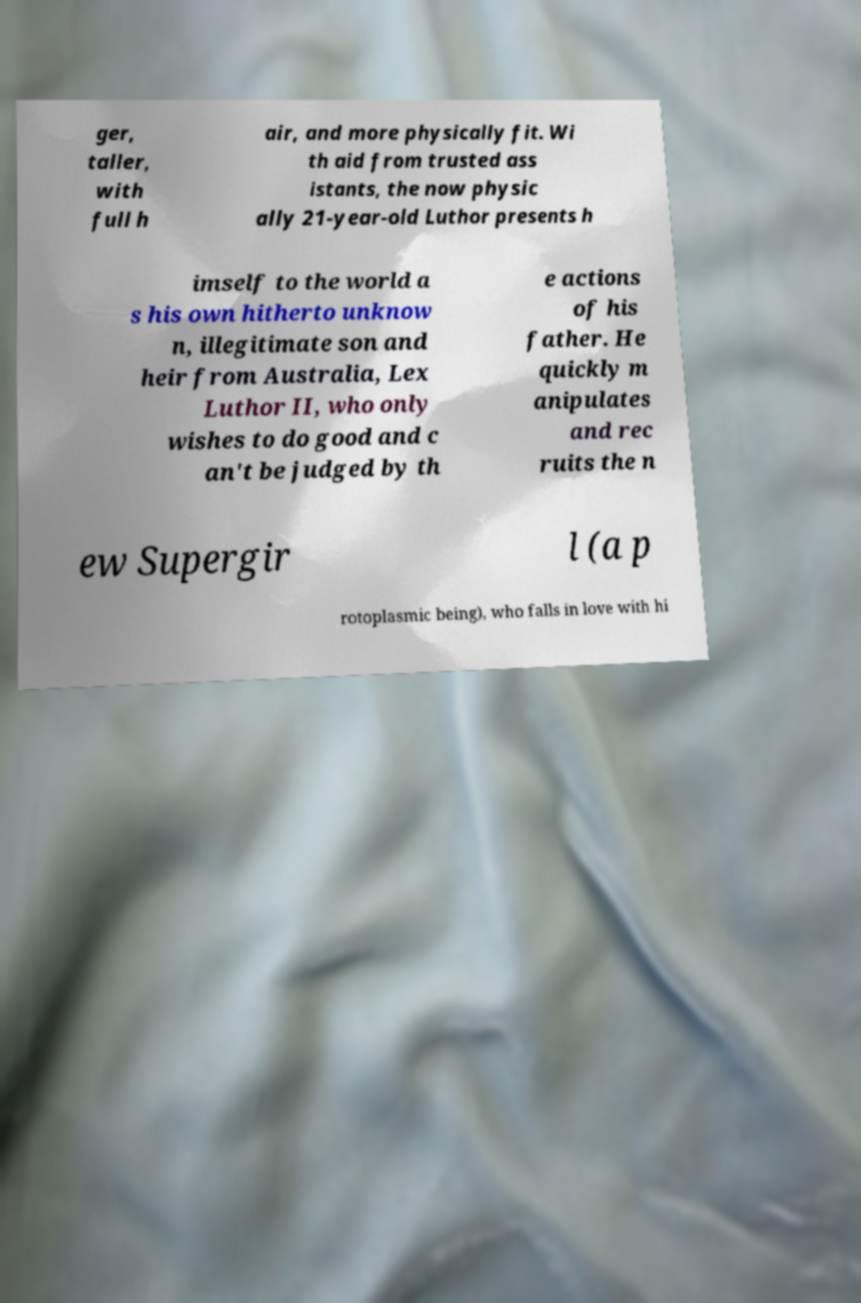Could you assist in decoding the text presented in this image and type it out clearly? ger, taller, with full h air, and more physically fit. Wi th aid from trusted ass istants, the now physic ally 21-year-old Luthor presents h imself to the world a s his own hitherto unknow n, illegitimate son and heir from Australia, Lex Luthor II, who only wishes to do good and c an't be judged by th e actions of his father. He quickly m anipulates and rec ruits the n ew Supergir l (a p rotoplasmic being), who falls in love with hi 